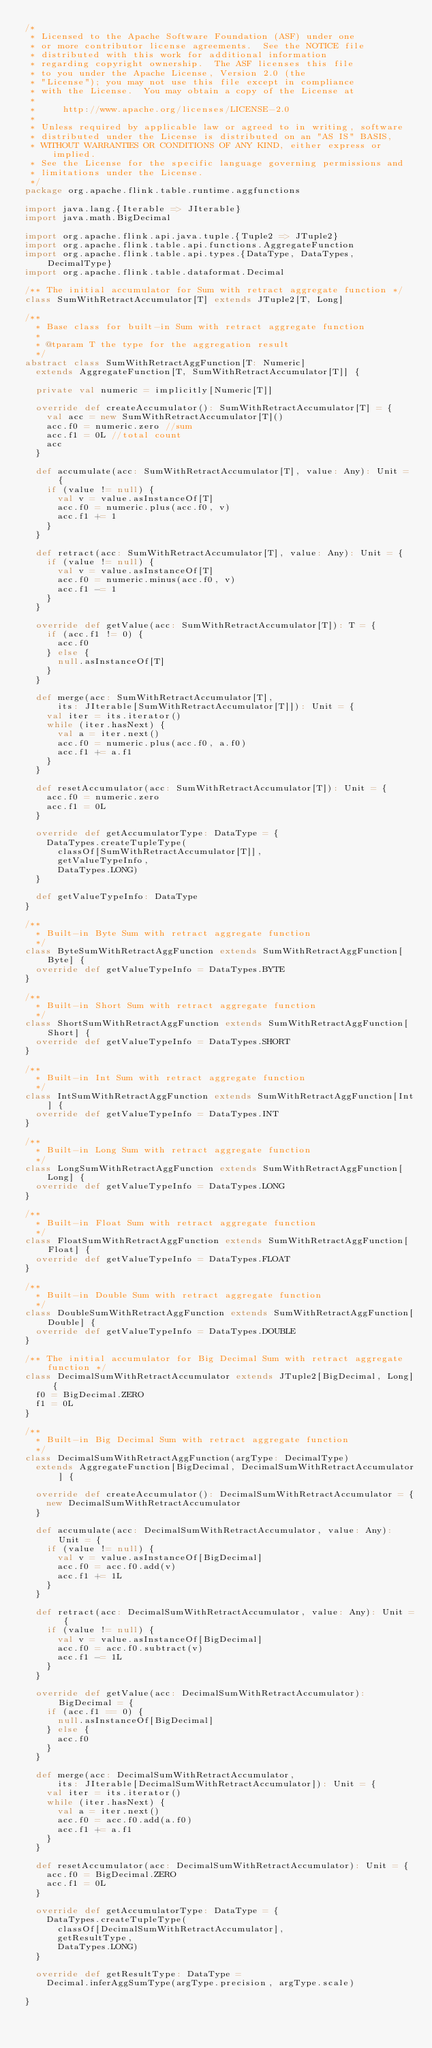Convert code to text. <code><loc_0><loc_0><loc_500><loc_500><_Scala_>/*
 * Licensed to the Apache Software Foundation (ASF) under one
 * or more contributor license agreements.  See the NOTICE file
 * distributed with this work for additional information
 * regarding copyright ownership.  The ASF licenses this file
 * to you under the Apache License, Version 2.0 (the
 * "License"); you may not use this file except in compliance
 * with the License.  You may obtain a copy of the License at
 *
 *     http://www.apache.org/licenses/LICENSE-2.0
 *
 * Unless required by applicable law or agreed to in writing, software
 * distributed under the License is distributed on an "AS IS" BASIS,
 * WITHOUT WARRANTIES OR CONDITIONS OF ANY KIND, either express or implied.
 * See the License for the specific language governing permissions and
 * limitations under the License.
 */
package org.apache.flink.table.runtime.aggfunctions

import java.lang.{Iterable => JIterable}
import java.math.BigDecimal

import org.apache.flink.api.java.tuple.{Tuple2 => JTuple2}
import org.apache.flink.table.api.functions.AggregateFunction
import org.apache.flink.table.api.types.{DataType, DataTypes, DecimalType}
import org.apache.flink.table.dataformat.Decimal

/** The initial accumulator for Sum with retract aggregate function */
class SumWithRetractAccumulator[T] extends JTuple2[T, Long]

/**
  * Base class for built-in Sum with retract aggregate function
  *
  * @tparam T the type for the aggregation result
  */
abstract class SumWithRetractAggFunction[T: Numeric]
  extends AggregateFunction[T, SumWithRetractAccumulator[T]] {

  private val numeric = implicitly[Numeric[T]]

  override def createAccumulator(): SumWithRetractAccumulator[T] = {
    val acc = new SumWithRetractAccumulator[T]()
    acc.f0 = numeric.zero //sum
    acc.f1 = 0L //total count
    acc
  }

  def accumulate(acc: SumWithRetractAccumulator[T], value: Any): Unit = {
    if (value != null) {
      val v = value.asInstanceOf[T]
      acc.f0 = numeric.plus(acc.f0, v)
      acc.f1 += 1
    }
  }

  def retract(acc: SumWithRetractAccumulator[T], value: Any): Unit = {
    if (value != null) {
      val v = value.asInstanceOf[T]
      acc.f0 = numeric.minus(acc.f0, v)
      acc.f1 -= 1
    }
  }

  override def getValue(acc: SumWithRetractAccumulator[T]): T = {
    if (acc.f1 != 0) {
      acc.f0
    } else {
      null.asInstanceOf[T]
    }
  }

  def merge(acc: SumWithRetractAccumulator[T],
      its: JIterable[SumWithRetractAccumulator[T]]): Unit = {
    val iter = its.iterator()
    while (iter.hasNext) {
      val a = iter.next()
      acc.f0 = numeric.plus(acc.f0, a.f0)
      acc.f1 += a.f1
    }
  }

  def resetAccumulator(acc: SumWithRetractAccumulator[T]): Unit = {
    acc.f0 = numeric.zero
    acc.f1 = 0L
  }

  override def getAccumulatorType: DataType = {
    DataTypes.createTupleType(
      classOf[SumWithRetractAccumulator[T]],
      getValueTypeInfo,
      DataTypes.LONG)
  }

  def getValueTypeInfo: DataType
}

/**
  * Built-in Byte Sum with retract aggregate function
  */
class ByteSumWithRetractAggFunction extends SumWithRetractAggFunction[Byte] {
  override def getValueTypeInfo = DataTypes.BYTE
}

/**
  * Built-in Short Sum with retract aggregate function
  */
class ShortSumWithRetractAggFunction extends SumWithRetractAggFunction[Short] {
  override def getValueTypeInfo = DataTypes.SHORT
}

/**
  * Built-in Int Sum with retract aggregate function
  */
class IntSumWithRetractAggFunction extends SumWithRetractAggFunction[Int] {
  override def getValueTypeInfo = DataTypes.INT
}

/**
  * Built-in Long Sum with retract aggregate function
  */
class LongSumWithRetractAggFunction extends SumWithRetractAggFunction[Long] {
  override def getValueTypeInfo = DataTypes.LONG
}

/**
  * Built-in Float Sum with retract aggregate function
  */
class FloatSumWithRetractAggFunction extends SumWithRetractAggFunction[Float] {
  override def getValueTypeInfo = DataTypes.FLOAT
}

/**
  * Built-in Double Sum with retract aggregate function
  */
class DoubleSumWithRetractAggFunction extends SumWithRetractAggFunction[Double] {
  override def getValueTypeInfo = DataTypes.DOUBLE
}

/** The initial accumulator for Big Decimal Sum with retract aggregate function */
class DecimalSumWithRetractAccumulator extends JTuple2[BigDecimal, Long] {
  f0 = BigDecimal.ZERO
  f1 = 0L
}

/**
  * Built-in Big Decimal Sum with retract aggregate function
  */
class DecimalSumWithRetractAggFunction(argType: DecimalType)
  extends AggregateFunction[BigDecimal, DecimalSumWithRetractAccumulator] {

  override def createAccumulator(): DecimalSumWithRetractAccumulator = {
    new DecimalSumWithRetractAccumulator
  }

  def accumulate(acc: DecimalSumWithRetractAccumulator, value: Any): Unit = {
    if (value != null) {
      val v = value.asInstanceOf[BigDecimal]
      acc.f0 = acc.f0.add(v)
      acc.f1 += 1L
    }
  }

  def retract(acc: DecimalSumWithRetractAccumulator, value: Any): Unit = {
    if (value != null) {
      val v = value.asInstanceOf[BigDecimal]
      acc.f0 = acc.f0.subtract(v)
      acc.f1 -= 1L
    }
  }

  override def getValue(acc: DecimalSumWithRetractAccumulator): BigDecimal = {
    if (acc.f1 == 0) {
      null.asInstanceOf[BigDecimal]
    } else {
      acc.f0
    }
  }

  def merge(acc: DecimalSumWithRetractAccumulator,
      its: JIterable[DecimalSumWithRetractAccumulator]): Unit = {
    val iter = its.iterator()
    while (iter.hasNext) {
      val a = iter.next()
      acc.f0 = acc.f0.add(a.f0)
      acc.f1 += a.f1
    }
  }

  def resetAccumulator(acc: DecimalSumWithRetractAccumulator): Unit = {
    acc.f0 = BigDecimal.ZERO
    acc.f1 = 0L
  }

  override def getAccumulatorType: DataType = {
    DataTypes.createTupleType(
      classOf[DecimalSumWithRetractAccumulator],
      getResultType,
      DataTypes.LONG)
  }

  override def getResultType: DataType =
    Decimal.inferAggSumType(argType.precision, argType.scale)

}
</code> 